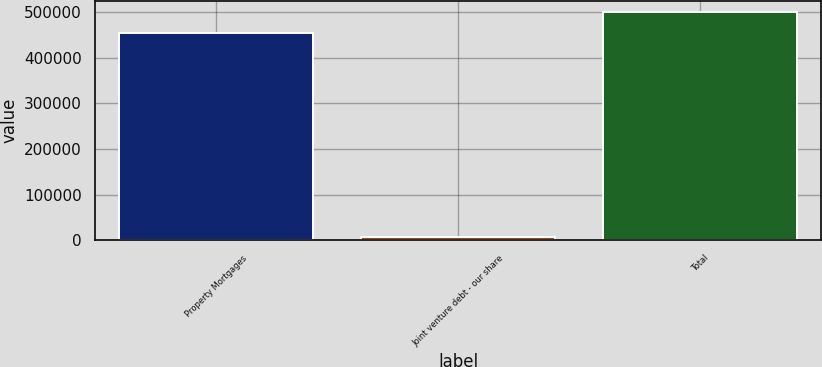Convert chart. <chart><loc_0><loc_0><loc_500><loc_500><bar_chart><fcel>Property Mortgages<fcel>Joint venture debt - our share<fcel>Total<nl><fcel>454396<fcel>6684<fcel>499836<nl></chart> 